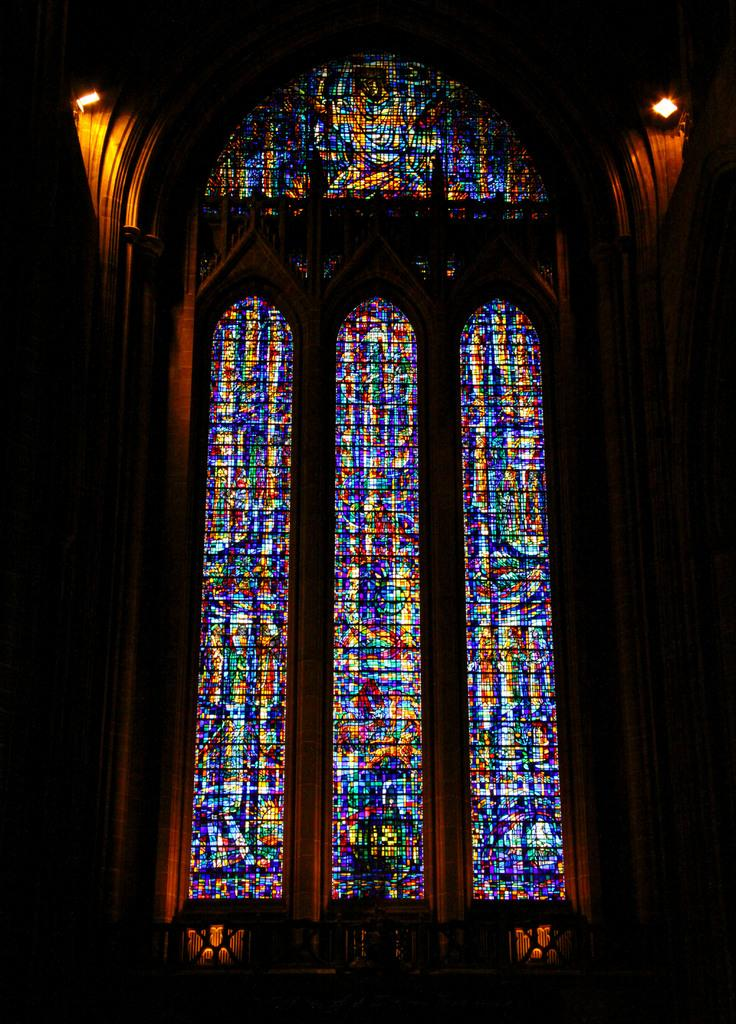What type of structure is depicted in the image? The image shows an inside view of a church wall. What can be seen on the church wall? The church wall has glasses and several colors. Are there any light sources visible in the image? Yes, there are lights on either side of the image. How would you describe the overall lighting in the image? The background is dark, which contrasts with the lights on either side. Can you see any children playing on a playground in the image? There is no playground or children visible in the image; it shows an inside view of a church wall. 